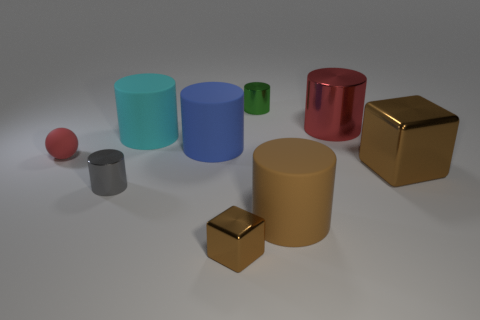Subtract 1 cylinders. How many cylinders are left? 5 Subtract all red cylinders. How many cylinders are left? 5 Subtract all big metal cylinders. How many cylinders are left? 5 Subtract all green cylinders. Subtract all cyan cubes. How many cylinders are left? 5 Add 1 large red shiny cylinders. How many objects exist? 10 Subtract all cylinders. How many objects are left? 3 Add 5 red rubber things. How many red rubber things exist? 6 Subtract 0 blue balls. How many objects are left? 9 Subtract all red things. Subtract all matte things. How many objects are left? 3 Add 8 cyan rubber things. How many cyan rubber things are left? 9 